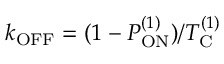Convert formula to latex. <formula><loc_0><loc_0><loc_500><loc_500>k _ { O F F } = ( 1 - P _ { O N } ^ { ( 1 ) } ) / T _ { C } ^ { ( 1 ) }</formula> 